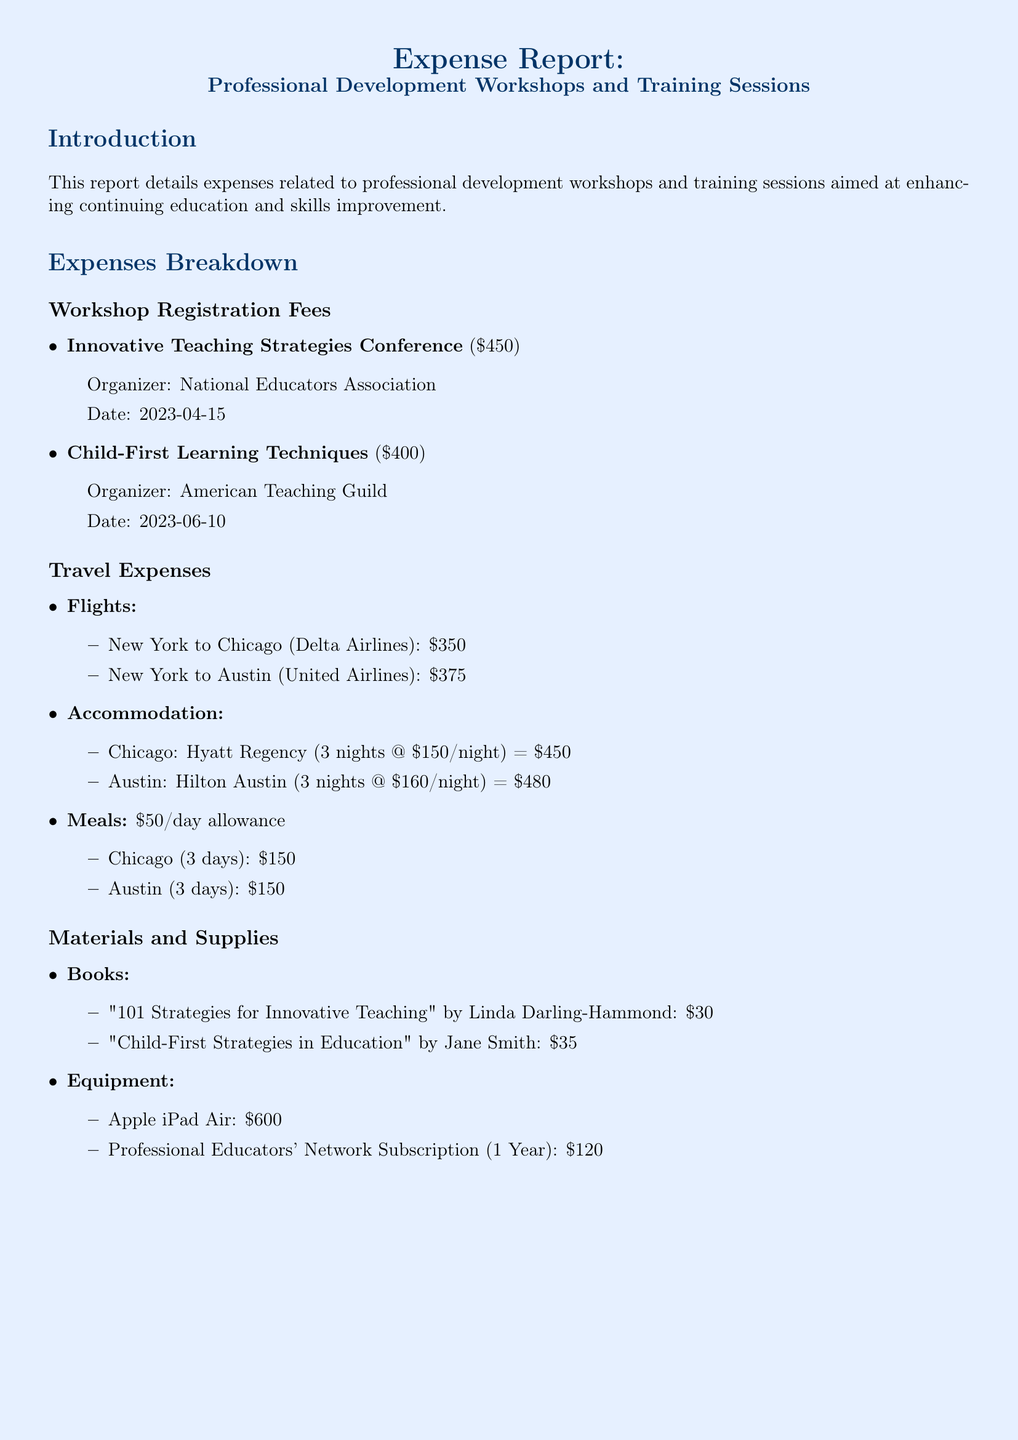What is the total expense amount? The total expenses are listed at the end of the report as the sum of all categories, which is $4,290.
Answer: $4,290 Who organized the Innovative Teaching Strategies Conference? The document specifies the organizer for each workshop, indicating that the Innovative Teaching Strategies Conference was organized by the National Educators Association.
Answer: National Educators Association How much was spent on meals in Chicago? The report details 3 days of meals at a daily allowance of $50, resulting in a total of $150 for meals in Chicago.
Answer: $150 What was the accommodation cost in Austin? The document lists the accommodation cost for 3 nights at Hilton Austin, which totals $480.
Answer: $480 Which book costs the least? The costs of the listed books are compared, identifying "101 Strategies for Innovative Teaching" by Linda Darling-Hammond as the cheapest at $30.
Answer: $30 What date was the Child-First Learning Techniques workshop held? The document provides the date for this workshop, which is June 10, 2023.
Answer: June 10, 2023 What is the daily allowance for meals? The daily meal allowance is specified in the document as $50 per day.
Answer: $50 How many nights was accommodation needed in Chicago? The report states that accommodation in Chicago was required for 3 nights.
Answer: 3 nights What is the cost of an Apple iPad Air? The document lists the price of the Apple iPad Air as $600.
Answer: $600 